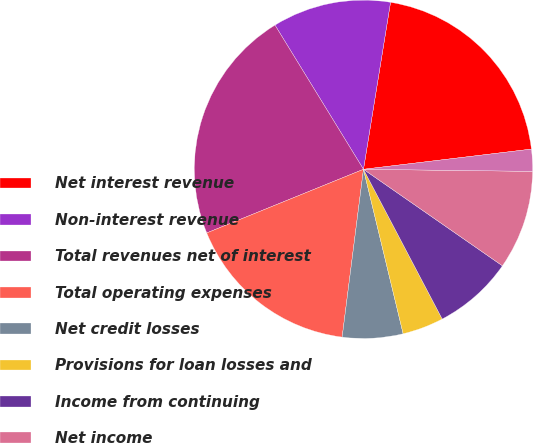<chart> <loc_0><loc_0><loc_500><loc_500><pie_chart><fcel>Net interest revenue<fcel>Non-interest revenue<fcel>Total revenues net of interest<fcel>Total operating expenses<fcel>Net credit losses<fcel>Provisions for loan losses and<fcel>Income from continuing<fcel>Net income<fcel>Average assets (in billions of<nl><fcel>20.54%<fcel>11.32%<fcel>22.38%<fcel>16.85%<fcel>5.78%<fcel>3.94%<fcel>7.63%<fcel>9.47%<fcel>2.1%<nl></chart> 